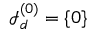Convert formula to latex. <formula><loc_0><loc_0><loc_500><loc_500>{ \mathcal { I } } _ { d } ^ { ( 0 ) } = \{ { 0 } \}</formula> 